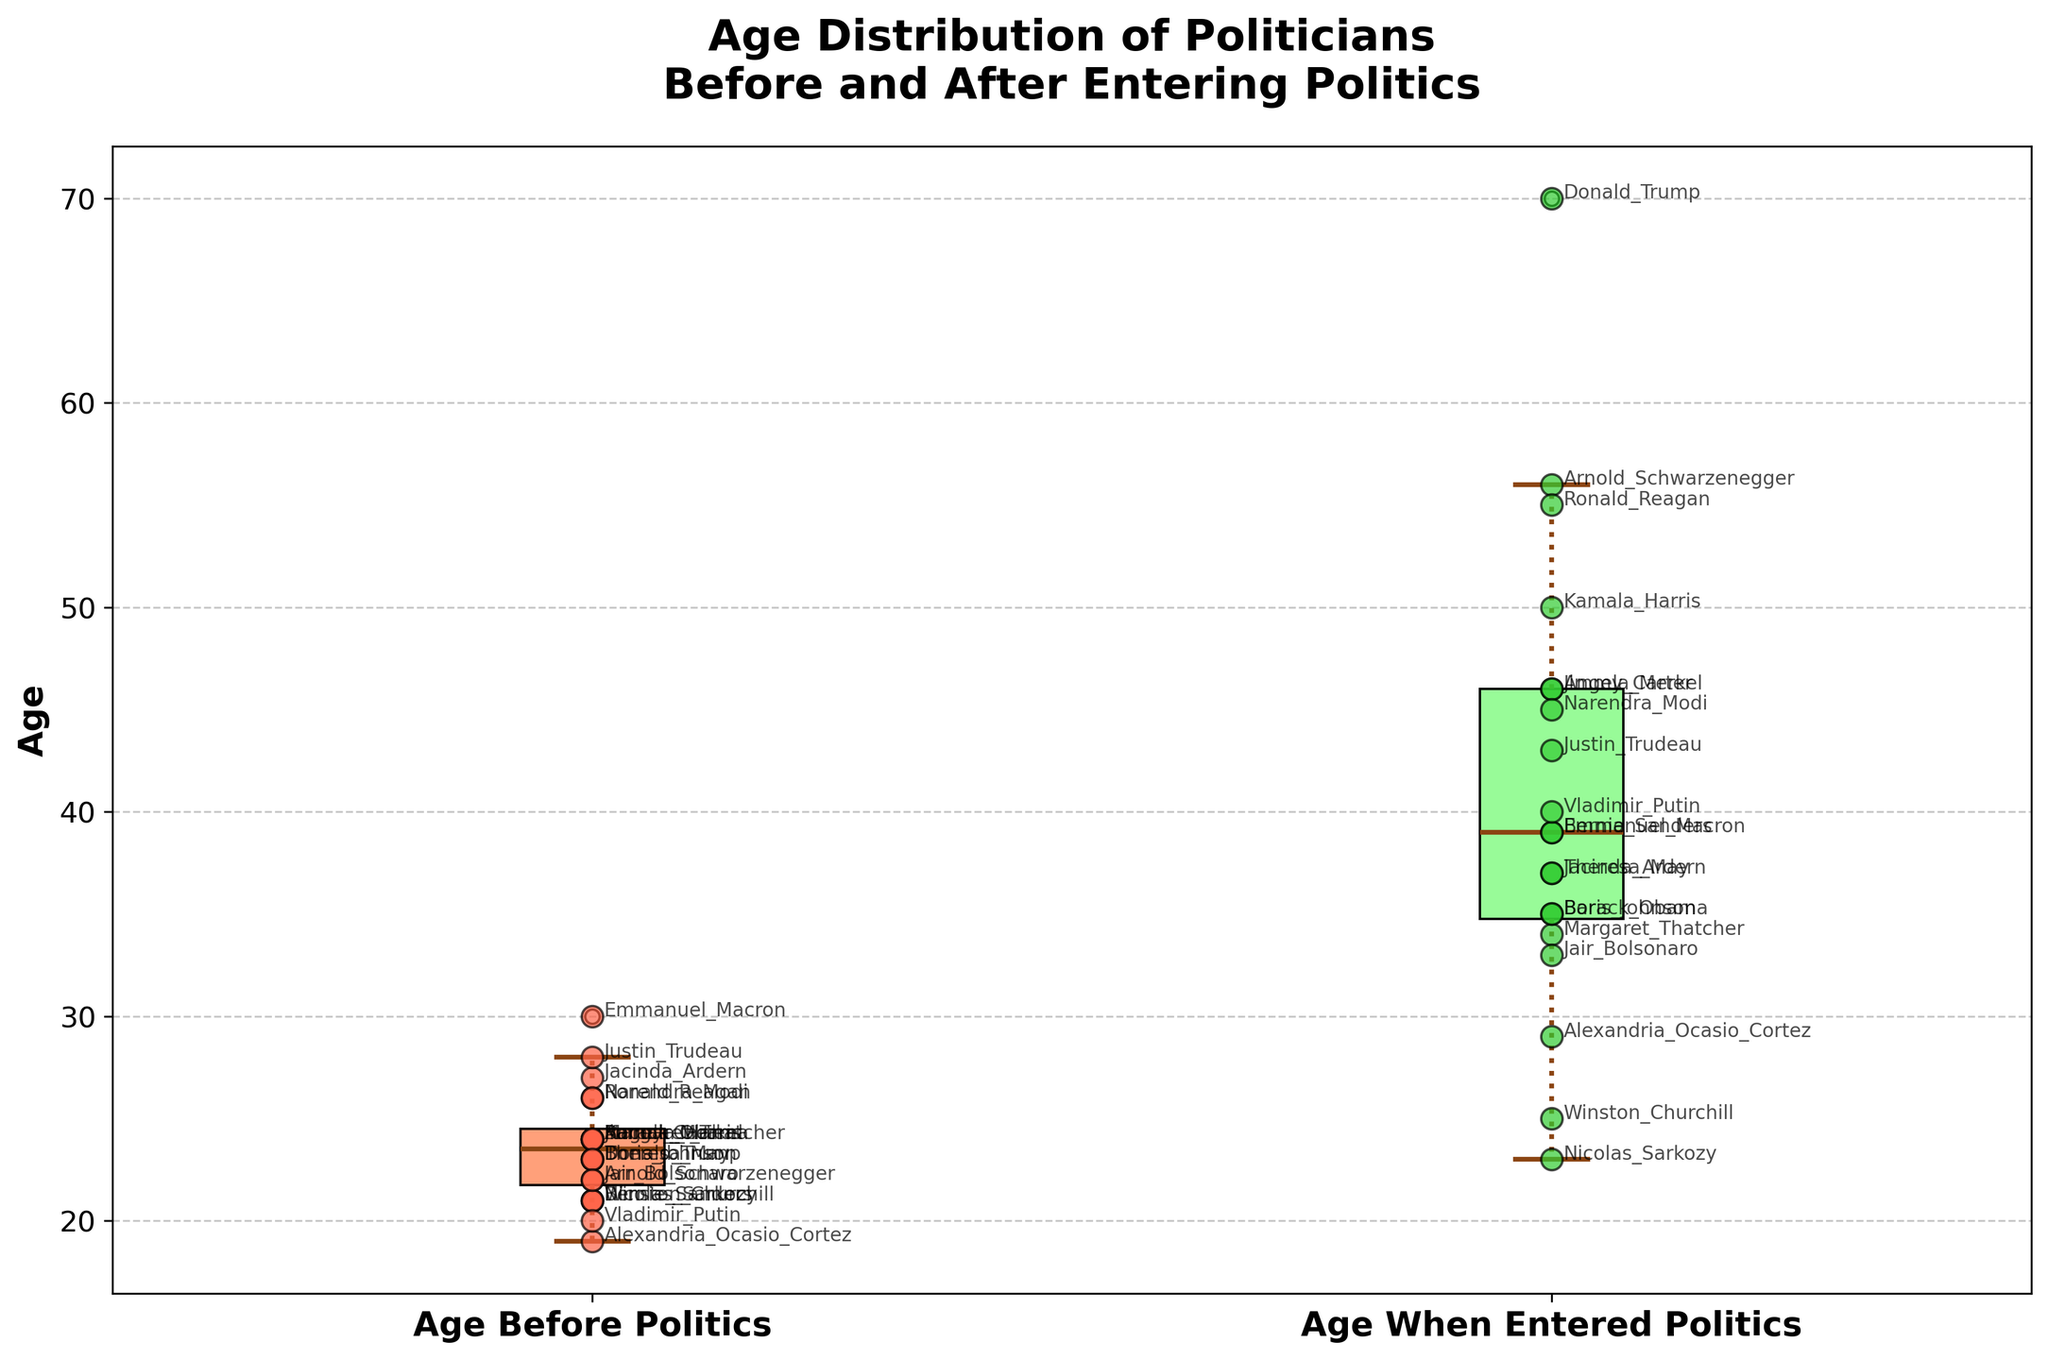What is the title of the plot? The title of the plot is usually found at the top, larger and bolded text providing an overview of the subject. In this case, it states "Age Distribution of Politicians Before and After Entering Politics".
Answer: Age Distribution of Politicians Before and After Entering Politics What are the labels on the x-axis? The x-axis labels typically represent the two groups being compared. Here, it shows "Age Before Politics" and "Age When Entered Politics".
Answer: Age Before Politics, Age When Entered Politics What color are the boxes in the box plot? By observing the visual representation, it's noted that the boxes are colored differently to distinguish the groups. One box is light salmon colored and the other is light green.
Answer: Light salmon and light green Which politician entered politics at the youngest age? To determine this, we check the scatter points on the "Age When Entered Politics" side and look for the lowest value, then identify the corresponding label. Nicolas Sarkozy entered at age 23 which is the youngest.
Answer: Nicolas Sarkozy Who had the largest age difference between before and when they entered politics? By calculating the differences for each politician and comparing them, Donald Trump had the largest gap between his age before entering politics (23) and the age he entered (70). This difference can be calculated as 70 - 23 = 47 years.
Answer: Donald Trump What is the median age of politicians before they entered politics? The median is typically indicated by the line inside the box for "Age Before Politics". Visually, it appears around 24 years.
Answer: Around 24 years What is the median age of politicians when they first entered politics? The median is typically indicated by the line inside the box for "Age When Entered Politics". Visually, it seems to be around 39 years.
Answer: Around 39 years How many data points (politicians) are shown on the plot? By counting the individual scatter points in both categories, it's clear that there are 20 data points (politicians) on the plot.
Answer: 20 Which group, before or when entering politics, has a greater range of ages? The range is calculated as the difference between the maximum and minimum values of each group. From the plot, the range for "Age Before Politics" spans approximately 10 to 30 years (a range of 20 years), and for "Age When Entered Politics" it spans from about 23 to 70 years (a range of 47 years). The "Age When Entered Politics" group has a greater range.
Answer: Age When Entered Politics Does any politician have an equal age before and when they entered politics? By observing and comparing data points on both sides of the plot, we notice that all politicians have a difference in their ages, none have equal ages in both categories.
Answer: No 